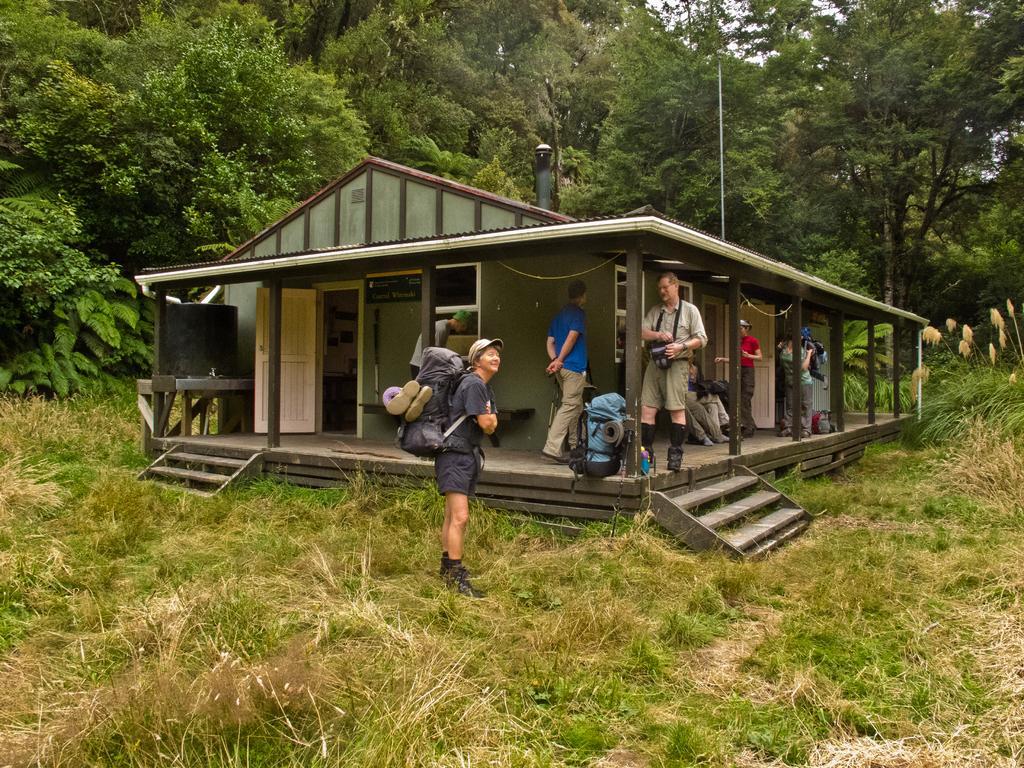Can you describe this image briefly? In this image there is a house, people, trees, grass and objects. Near them there are luggages.   